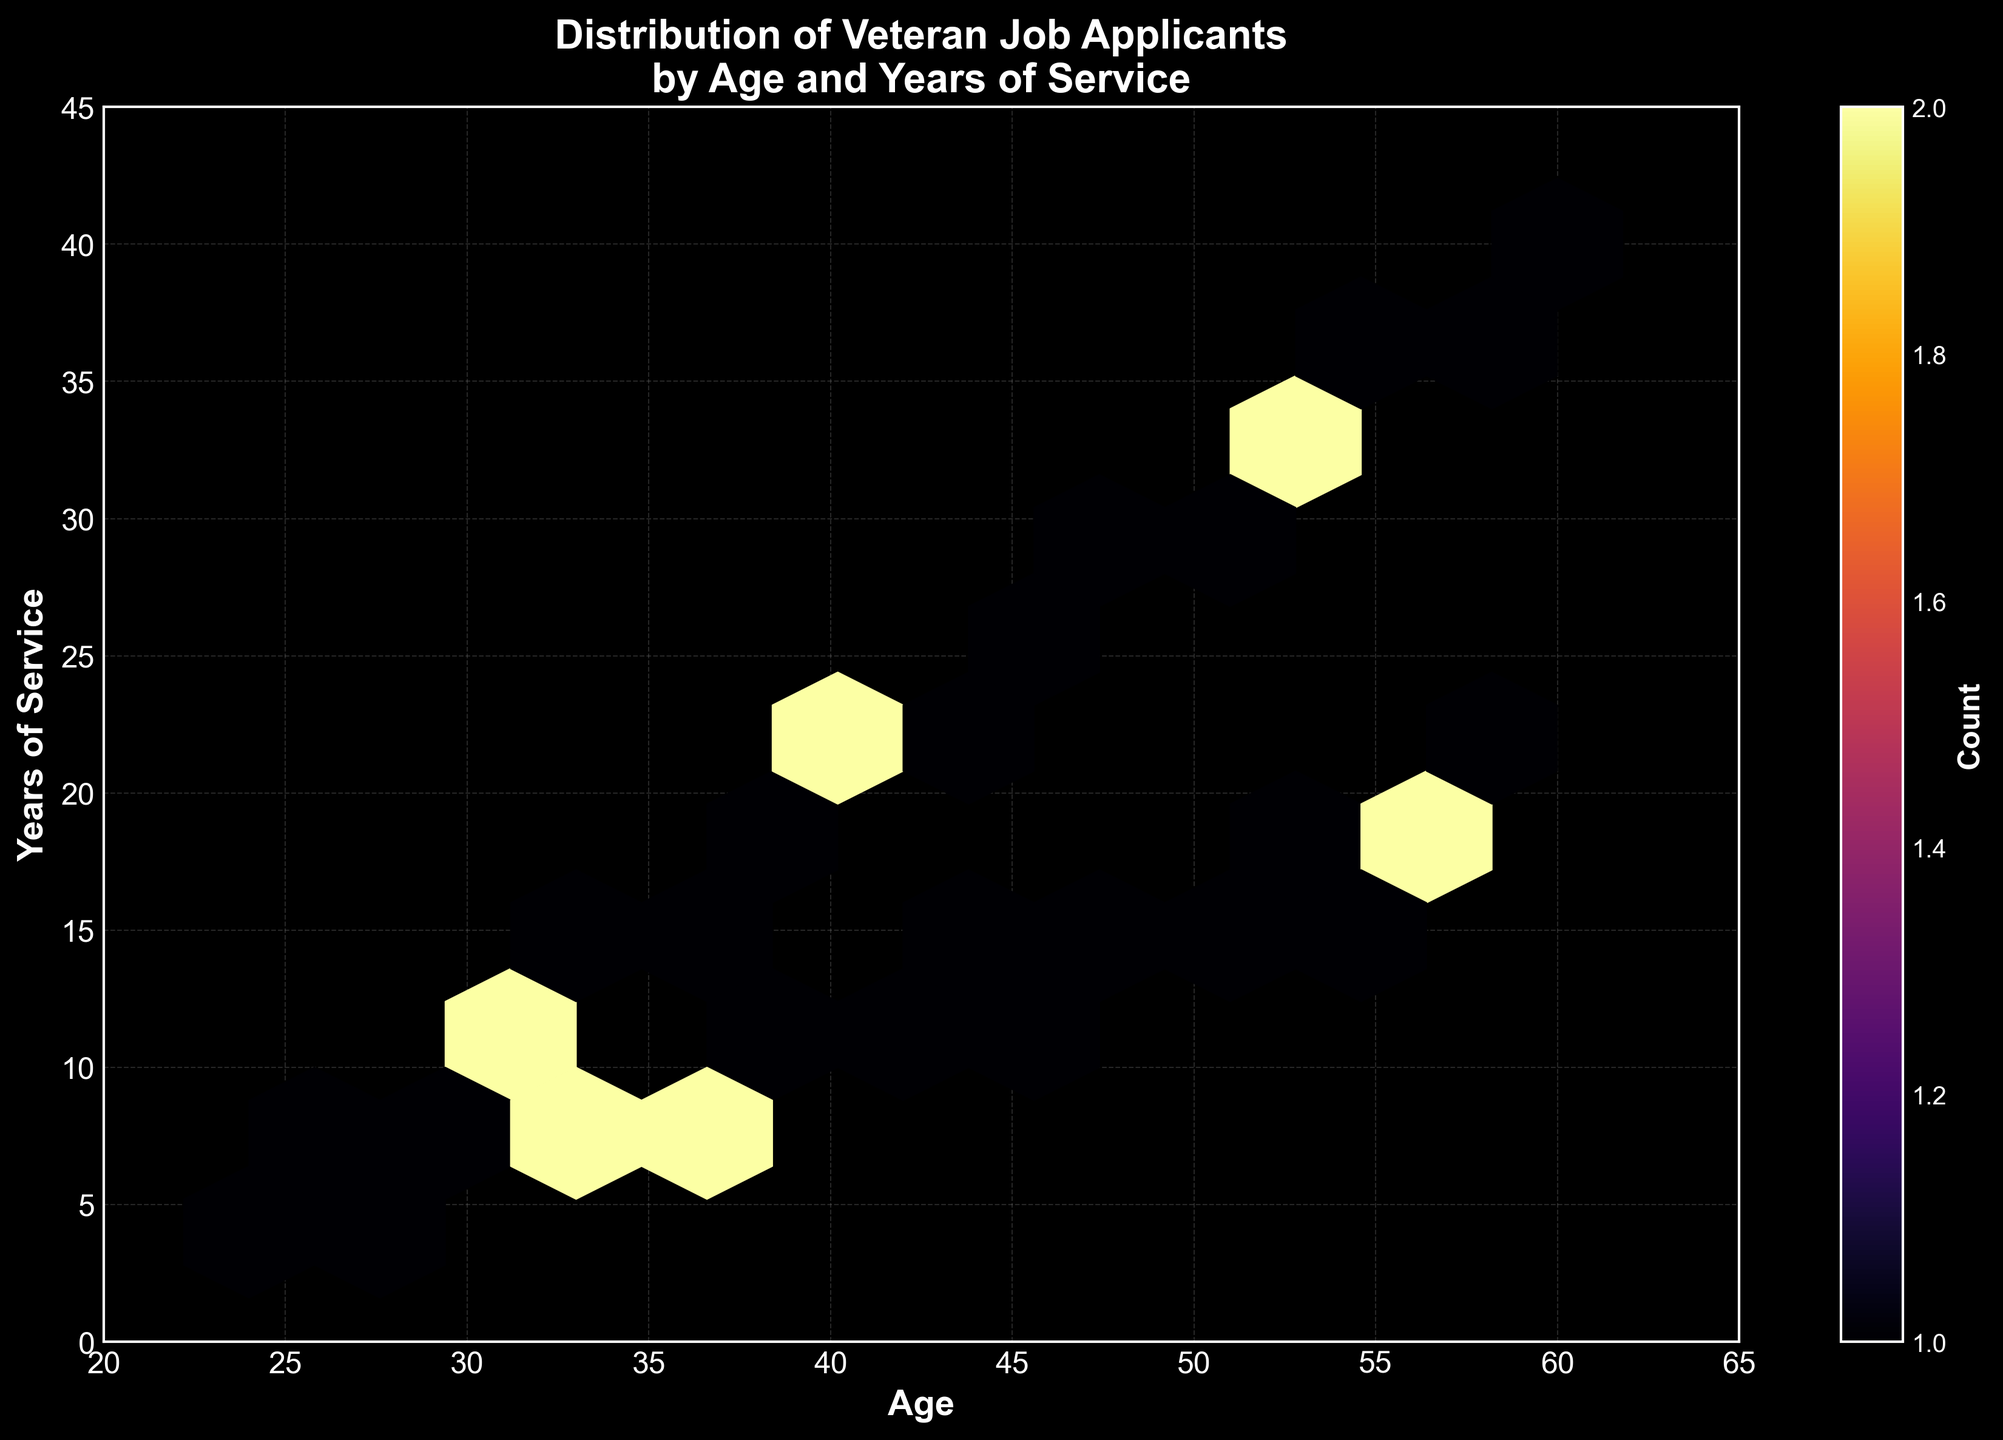What's the title of the plot? The title is located at the top center of the plot. The exact text of the title is "Distribution of Veteran Job Applicants by Age and Years of Service".
Answer: Distribution of Veteran Job Applicants by Age and Years of Service What are the x-axis and y-axis labels? The x-axis label is found at the bottom of the horizontal axis, and the y-axis label is found along the vertical axis. The x-axis label is "Age", and the y-axis label is "Years of Service".
Answer: Age, Years of Service How many hexagons show a count of veteran job applicants? To count the hexagons with applicants, look for the color bar labels and identify hexagons with corresponding colors. We'll count the total hexagons visible on the plot.
Answer: 22 Where on the plot do you see the highest concentration of veteran job applicants? The highest concentration is indicated by the darkest color according to the color bar labeled "Count". This concentration occurs where hexagons are the darkest.
Answer: Around Age 40 and Years of Service 20 Is there a noticeable pattern in the distribution of age and years of service among veterans? We need to observe if the points form a trend. The hexagons tend to form a linear pattern upward as the age increases, indicating a positive correlation between age and years of service.
Answer: Positive correlation pattern What is the average age of veteran job applicants with 10 years of service? We need to find all points around 10 years of service and calculate the average age. The points are approximately at ages 30 and 42. The average age is (30 + 42) / 2 = 36.
Answer: 36 Which group, younger veterans or older veterans, tend to have fewer years of service? By inspecting the lower section of the plot (young age) and upper section (old age), younger veterans (left side of the x-axis) generally have fewer years of service compared to older veterans on the right side.
Answer: Younger veterans Does the color gradient change indicate a uniform distribution of veteran job applicants? By looking at the hexbin color distribution, a uniform distribution would mean a smooth gradient. The colors are not uniformly distributed, indicating clusters and varying concentrations of applicants.
Answer: No Do veterans aged 50 or older show more or less variation in years of service compared to those aged 30 or younger? Examine the spread of hexagons for veterans aged >50 and <30. Veterans aged >50 show more spread in years of service, indicating greater variation compared to <30 where the range is narrow.
Answer: More variation 